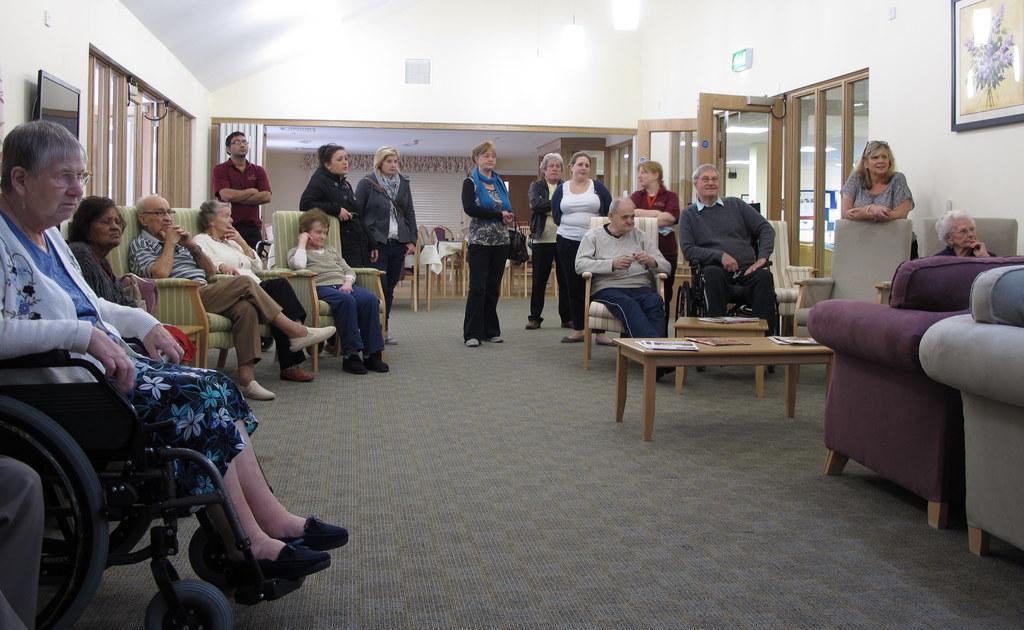Can you describe this image briefly? In the image we can see there are lot of people who are sitting on chair and others are standing at the back. 